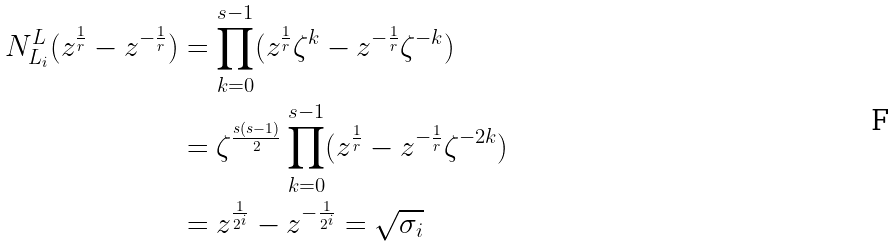<formula> <loc_0><loc_0><loc_500><loc_500>N ^ { L } _ { L _ { i } } ( z ^ { \frac { 1 } { r } } - z ^ { - \frac { 1 } { r } } ) & = \prod _ { k = 0 } ^ { s - 1 } ( z ^ { \frac { 1 } { r } } \zeta ^ { k } - z ^ { - \frac { 1 } { r } } \zeta ^ { - k } ) \\ & = \zeta ^ { \frac { s ( s - 1 ) } { 2 } } \prod _ { k = 0 } ^ { s - 1 } ( z ^ { \frac { 1 } { r } } - z ^ { - \frac { 1 } { r } } \zeta ^ { - 2 k } ) \\ & = z ^ { \frac { 1 } { 2 ^ { i } } } - z ^ { - \frac { 1 } { 2 ^ { i } } } = \sqrt { \sigma _ { i } }</formula> 